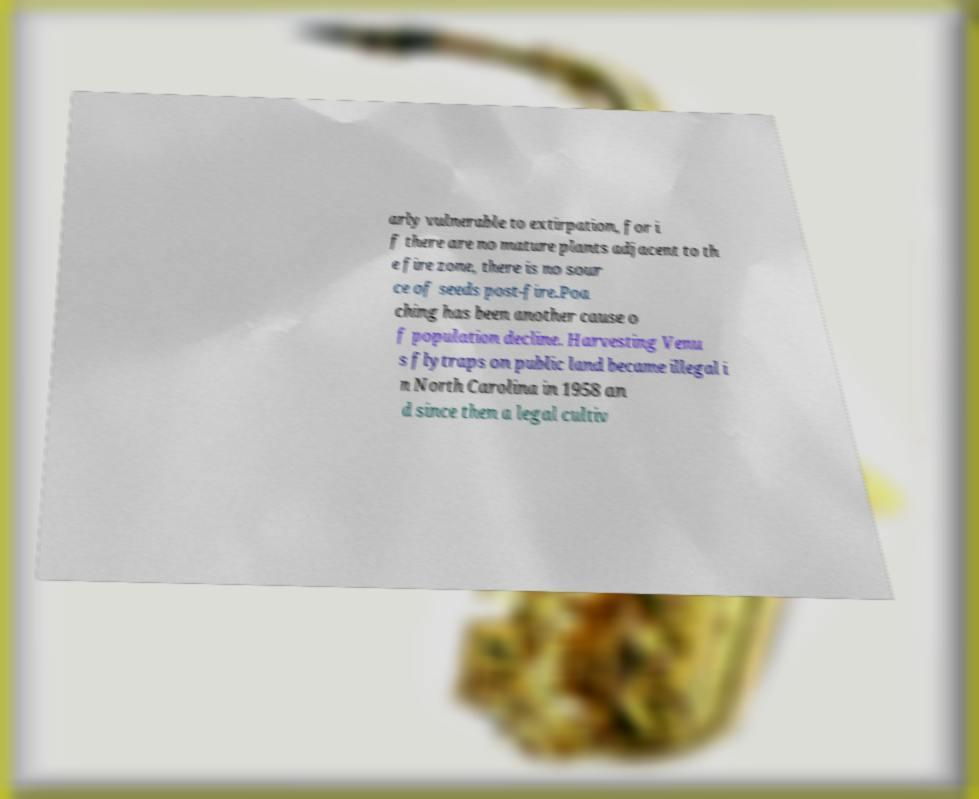Can you read and provide the text displayed in the image?This photo seems to have some interesting text. Can you extract and type it out for me? arly vulnerable to extirpation, for i f there are no mature plants adjacent to th e fire zone, there is no sour ce of seeds post-fire.Poa ching has been another cause o f population decline. Harvesting Venu s flytraps on public land became illegal i n North Carolina in 1958 an d since then a legal cultiv 